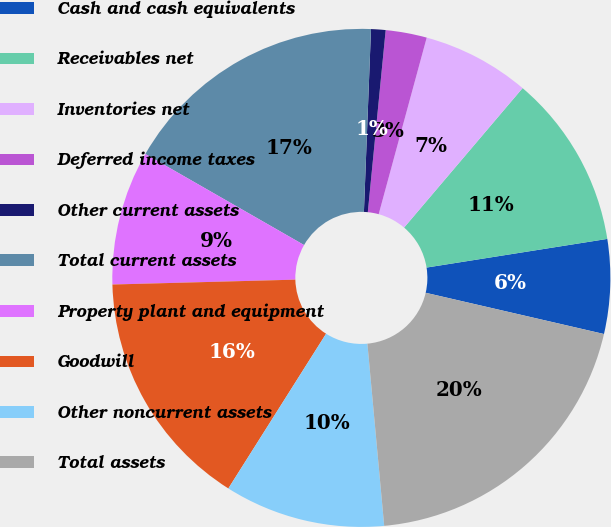Convert chart. <chart><loc_0><loc_0><loc_500><loc_500><pie_chart><fcel>Cash and cash equivalents<fcel>Receivables net<fcel>Inventories net<fcel>Deferred income taxes<fcel>Other current assets<fcel>Total current assets<fcel>Property plant and equipment<fcel>Goodwill<fcel>Other noncurrent assets<fcel>Total assets<nl><fcel>6.12%<fcel>11.29%<fcel>6.98%<fcel>2.67%<fcel>0.94%<fcel>17.33%<fcel>8.71%<fcel>15.61%<fcel>10.43%<fcel>19.92%<nl></chart> 